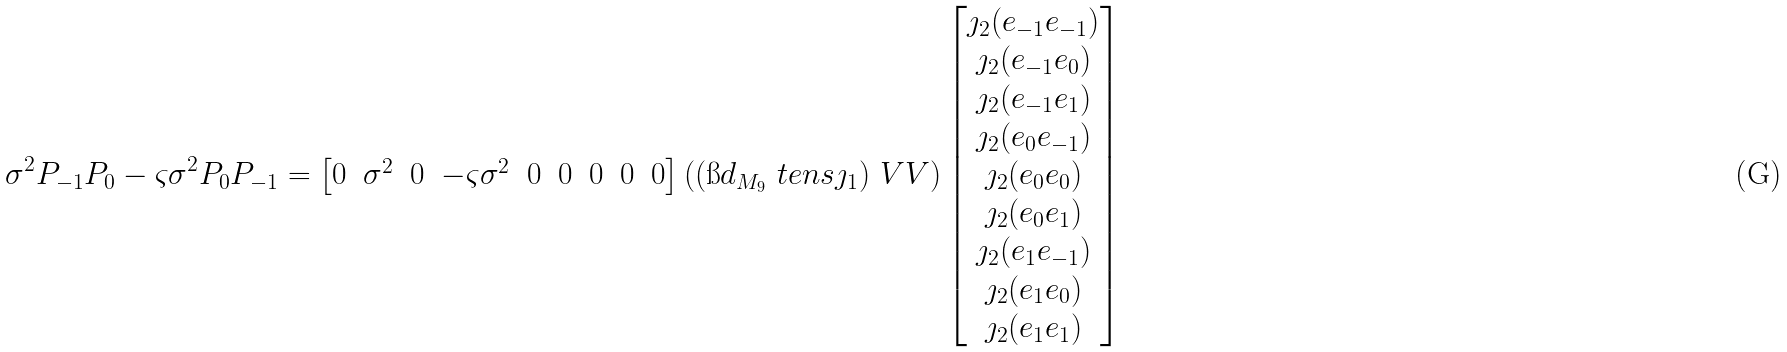<formula> <loc_0><loc_0><loc_500><loc_500>\sigma ^ { 2 } P _ { - 1 } P _ { 0 } & - \varsigma \sigma ^ { 2 } P _ { 0 } P _ { - 1 } = \begin{bmatrix} 0 & \sigma ^ { 2 } & 0 & - \varsigma \sigma ^ { 2 } & 0 & 0 & 0 & 0 & 0 \end{bmatrix} \left ( ( \i d _ { M _ { 9 } } \ t e n s \jmath _ { 1 } ) \ V V \right ) \begin{bmatrix} \jmath _ { 2 } ( e _ { - 1 } e _ { - 1 } ) \\ \jmath _ { 2 } ( e _ { - 1 } e _ { 0 } ) \\ \jmath _ { 2 } ( e _ { - 1 } e _ { 1 } ) \\ \jmath _ { 2 } ( e _ { 0 } e _ { - 1 } ) \\ \jmath _ { 2 } ( e _ { 0 } e _ { 0 } ) \\ \jmath _ { 2 } ( e _ { 0 } e _ { 1 } ) \\ \jmath _ { 2 } ( e _ { 1 } e _ { - 1 } ) \\ \jmath _ { 2 } ( e _ { 1 } e _ { 0 } ) \\ \jmath _ { 2 } ( e _ { 1 } e _ { 1 } ) \end{bmatrix}</formula> 